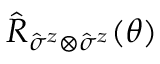Convert formula to latex. <formula><loc_0><loc_0><loc_500><loc_500>\hat { R } _ { { \hat { \sigma } } ^ { z } \otimes { \hat { \sigma } } ^ { z } } ( \theta )</formula> 